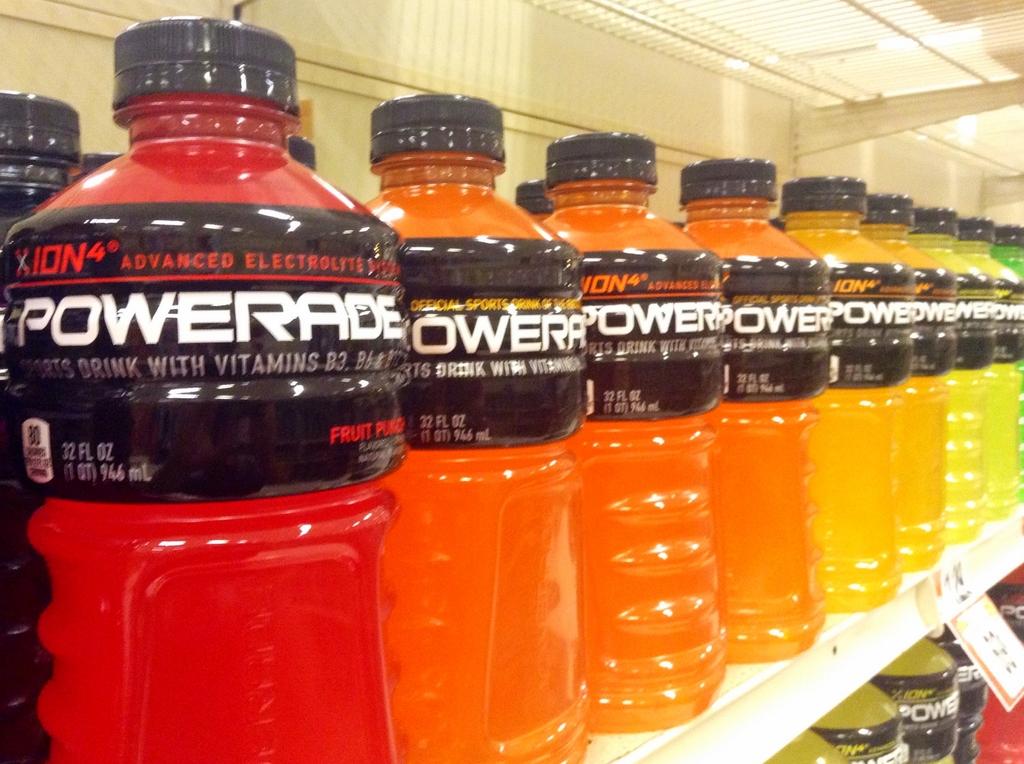What brand of thirst quencher is displayed?
Your answer should be compact. Powerade. 